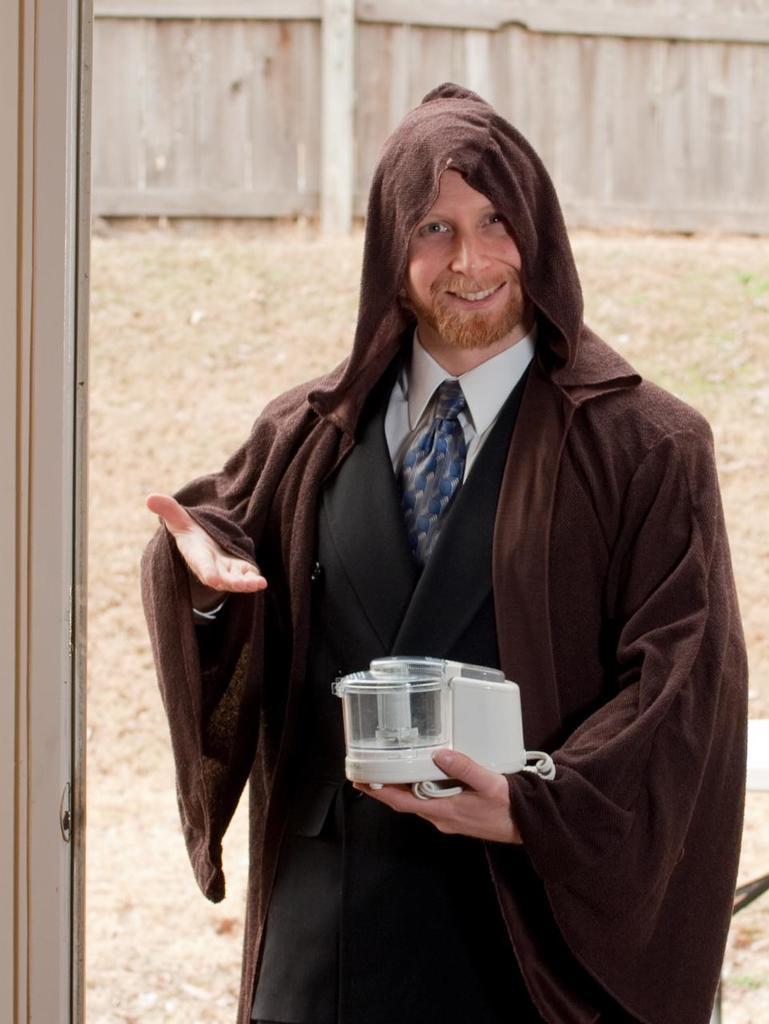Can you describe this image briefly? In this there is a man he is wearing a coat and holding an object in his hand, in the background there is a wall. 